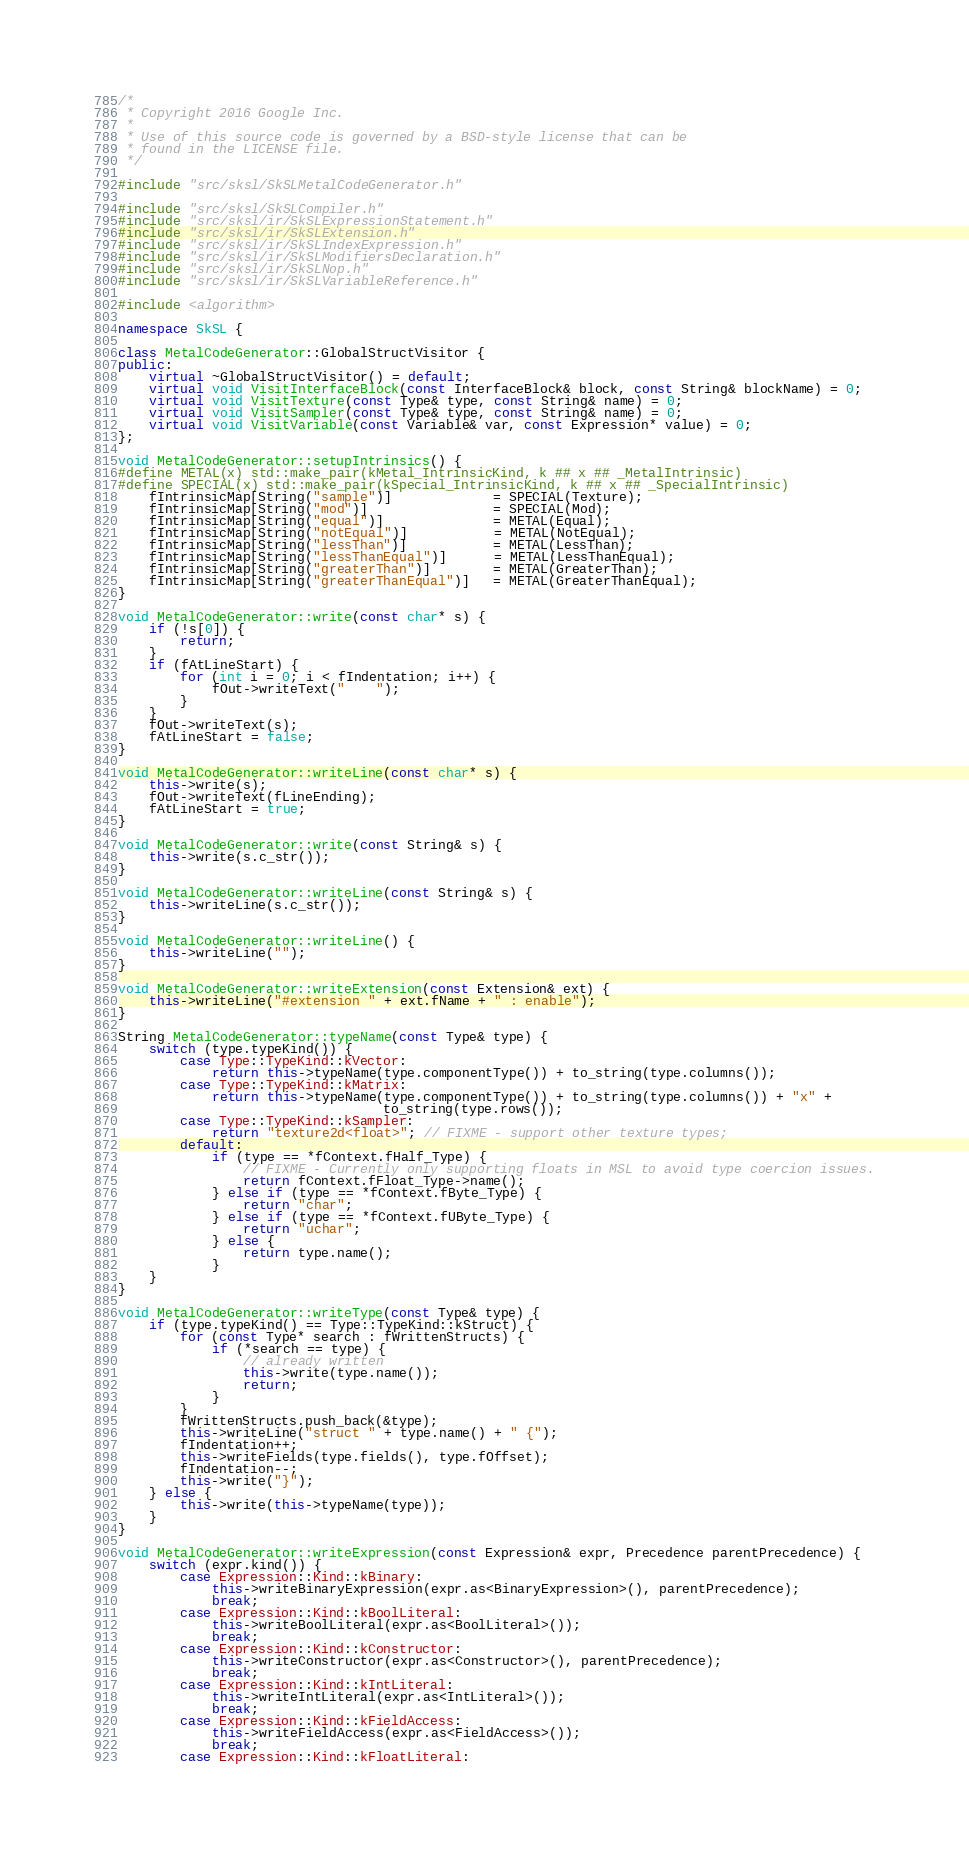<code> <loc_0><loc_0><loc_500><loc_500><_C++_>/*
 * Copyright 2016 Google Inc.
 *
 * Use of this source code is governed by a BSD-style license that can be
 * found in the LICENSE file.
 */

#include "src/sksl/SkSLMetalCodeGenerator.h"

#include "src/sksl/SkSLCompiler.h"
#include "src/sksl/ir/SkSLExpressionStatement.h"
#include "src/sksl/ir/SkSLExtension.h"
#include "src/sksl/ir/SkSLIndexExpression.h"
#include "src/sksl/ir/SkSLModifiersDeclaration.h"
#include "src/sksl/ir/SkSLNop.h"
#include "src/sksl/ir/SkSLVariableReference.h"

#include <algorithm>

namespace SkSL {

class MetalCodeGenerator::GlobalStructVisitor {
public:
    virtual ~GlobalStructVisitor() = default;
    virtual void VisitInterfaceBlock(const InterfaceBlock& block, const String& blockName) = 0;
    virtual void VisitTexture(const Type& type, const String& name) = 0;
    virtual void VisitSampler(const Type& type, const String& name) = 0;
    virtual void VisitVariable(const Variable& var, const Expression* value) = 0;
};

void MetalCodeGenerator::setupIntrinsics() {
#define METAL(x) std::make_pair(kMetal_IntrinsicKind, k ## x ## _MetalIntrinsic)
#define SPECIAL(x) std::make_pair(kSpecial_IntrinsicKind, k ## x ## _SpecialIntrinsic)
    fIntrinsicMap[String("sample")]             = SPECIAL(Texture);
    fIntrinsicMap[String("mod")]                = SPECIAL(Mod);
    fIntrinsicMap[String("equal")]              = METAL(Equal);
    fIntrinsicMap[String("notEqual")]           = METAL(NotEqual);
    fIntrinsicMap[String("lessThan")]           = METAL(LessThan);
    fIntrinsicMap[String("lessThanEqual")]      = METAL(LessThanEqual);
    fIntrinsicMap[String("greaterThan")]        = METAL(GreaterThan);
    fIntrinsicMap[String("greaterThanEqual")]   = METAL(GreaterThanEqual);
}

void MetalCodeGenerator::write(const char* s) {
    if (!s[0]) {
        return;
    }
    if (fAtLineStart) {
        for (int i = 0; i < fIndentation; i++) {
            fOut->writeText("    ");
        }
    }
    fOut->writeText(s);
    fAtLineStart = false;
}

void MetalCodeGenerator::writeLine(const char* s) {
    this->write(s);
    fOut->writeText(fLineEnding);
    fAtLineStart = true;
}

void MetalCodeGenerator::write(const String& s) {
    this->write(s.c_str());
}

void MetalCodeGenerator::writeLine(const String& s) {
    this->writeLine(s.c_str());
}

void MetalCodeGenerator::writeLine() {
    this->writeLine("");
}

void MetalCodeGenerator::writeExtension(const Extension& ext) {
    this->writeLine("#extension " + ext.fName + " : enable");
}

String MetalCodeGenerator::typeName(const Type& type) {
    switch (type.typeKind()) {
        case Type::TypeKind::kVector:
            return this->typeName(type.componentType()) + to_string(type.columns());
        case Type::TypeKind::kMatrix:
            return this->typeName(type.componentType()) + to_string(type.columns()) + "x" +
                                  to_string(type.rows());
        case Type::TypeKind::kSampler:
            return "texture2d<float>"; // FIXME - support other texture types;
        default:
            if (type == *fContext.fHalf_Type) {
                // FIXME - Currently only supporting floats in MSL to avoid type coercion issues.
                return fContext.fFloat_Type->name();
            } else if (type == *fContext.fByte_Type) {
                return "char";
            } else if (type == *fContext.fUByte_Type) {
                return "uchar";
            } else {
                return type.name();
            }
    }
}

void MetalCodeGenerator::writeType(const Type& type) {
    if (type.typeKind() == Type::TypeKind::kStruct) {
        for (const Type* search : fWrittenStructs) {
            if (*search == type) {
                // already written
                this->write(type.name());
                return;
            }
        }
        fWrittenStructs.push_back(&type);
        this->writeLine("struct " + type.name() + " {");
        fIndentation++;
        this->writeFields(type.fields(), type.fOffset);
        fIndentation--;
        this->write("}");
    } else {
        this->write(this->typeName(type));
    }
}

void MetalCodeGenerator::writeExpression(const Expression& expr, Precedence parentPrecedence) {
    switch (expr.kind()) {
        case Expression::Kind::kBinary:
            this->writeBinaryExpression(expr.as<BinaryExpression>(), parentPrecedence);
            break;
        case Expression::Kind::kBoolLiteral:
            this->writeBoolLiteral(expr.as<BoolLiteral>());
            break;
        case Expression::Kind::kConstructor:
            this->writeConstructor(expr.as<Constructor>(), parentPrecedence);
            break;
        case Expression::Kind::kIntLiteral:
            this->writeIntLiteral(expr.as<IntLiteral>());
            break;
        case Expression::Kind::kFieldAccess:
            this->writeFieldAccess(expr.as<FieldAccess>());
            break;
        case Expression::Kind::kFloatLiteral:</code> 